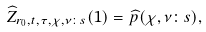<formula> <loc_0><loc_0><loc_500><loc_500>\widehat { Z } _ { r _ { 0 } , t , \tau , \chi , \nu \colon s } ( 1 ) = \widehat { p } ( \chi , \nu \colon s ) ,</formula> 